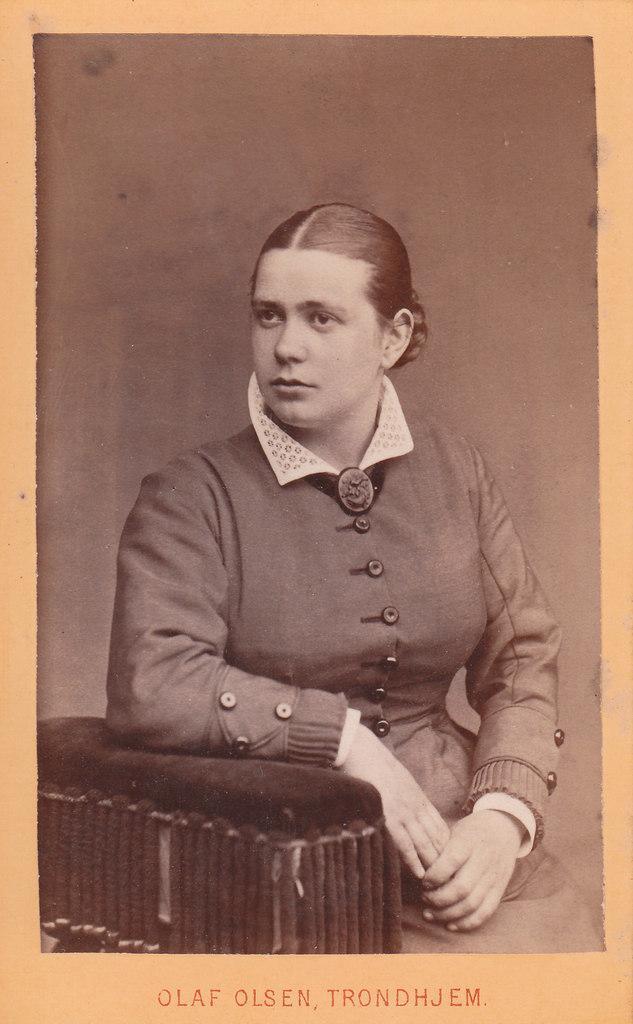How would you summarize this image in a sentence or two? This picture consists of a photograph in the image, in which there is a girl in the image. 